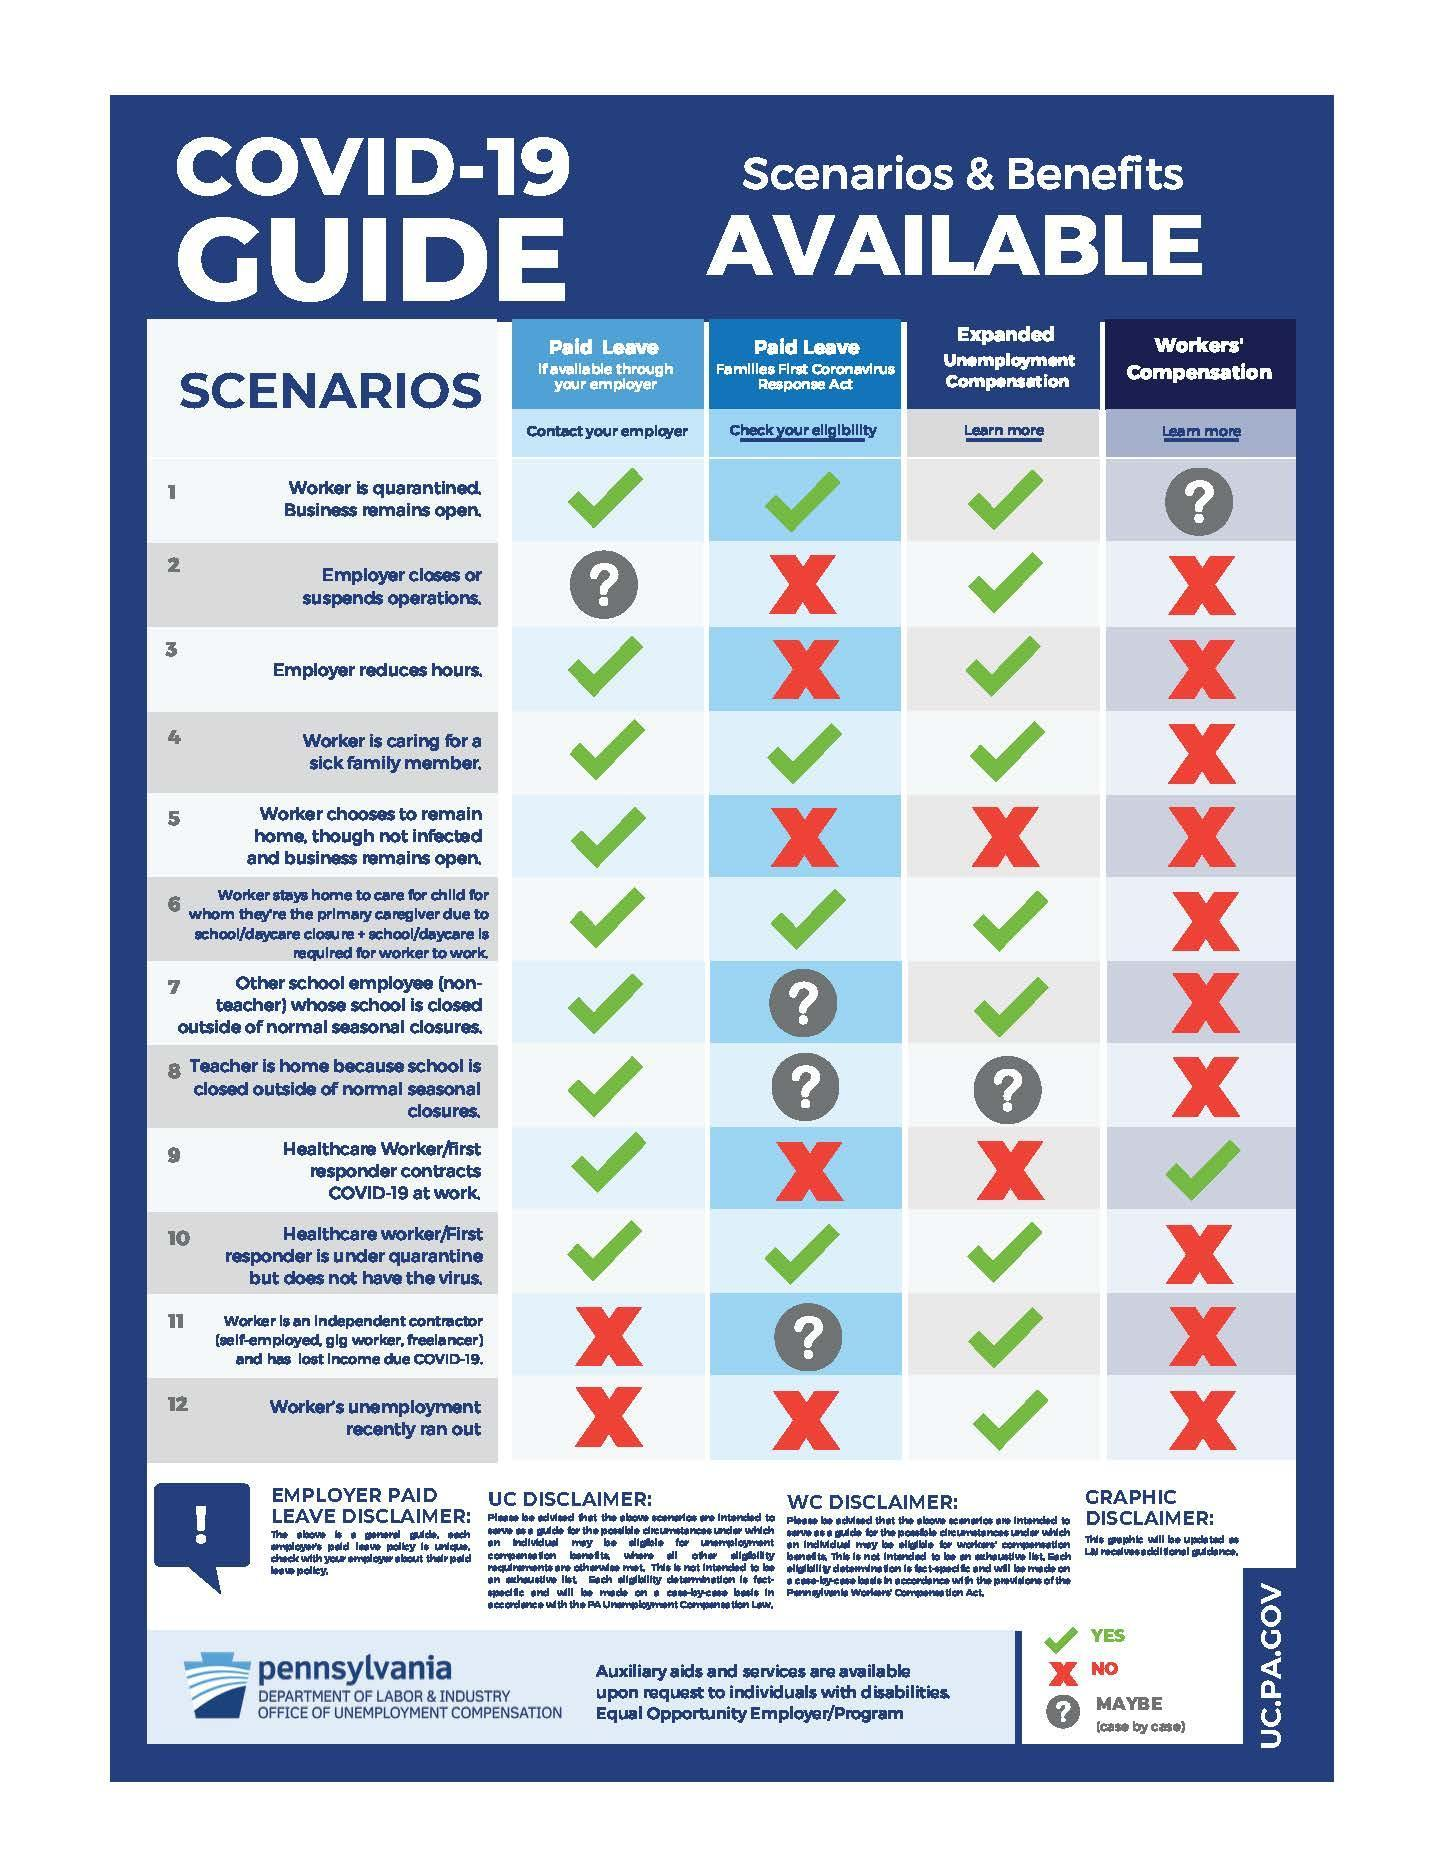What colour is the tick mark -red, blue or green?
Answer the question with a short phrase. green What does question mark icon indicate? MAYBE (case by case) What does tick mark represent? YES How many question mark icons are there in the infographic? 7 How many tick marks are there in total? 24 What colour is the cross mark -red, blue or green? red How many cross marks are there in total? 20 What does cross mark indicate? NO 